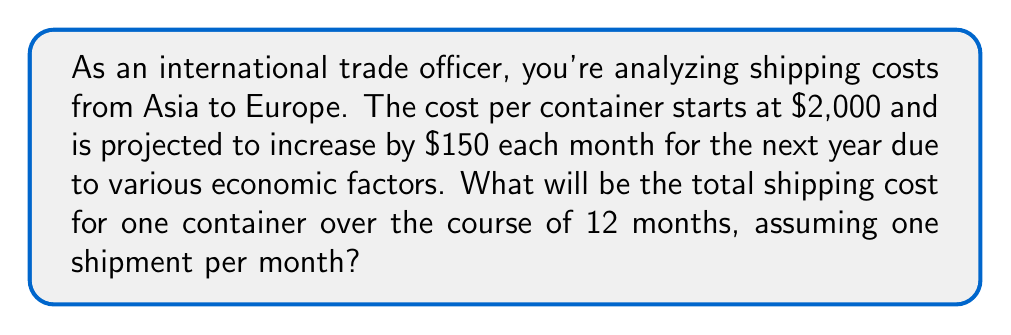Could you help me with this problem? Let's approach this step-by-step using arithmetic progression:

1) The initial term (a₁) is $2,000
2) The common difference (d) is $150
3) We need to find the sum of 12 terms

The arithmetic sequence is:
$2000, 2150, 2300, 2450, ...$

To find the sum, we can use the arithmetic series formula:

$$ S_n = \frac{n}{2}(a_1 + a_n) $$

Where:
$S_n$ is the sum of the series
$n$ is the number of terms (12)
$a_1$ is the first term ($2,000)
$a_n$ is the last term

To find $a_n$, we use the arithmetic sequence formula:
$$ a_n = a_1 + (n-1)d $$
$$ a_{12} = 2000 + (12-1)150 = 2000 + 1650 = 3650 $$

Now we can calculate the sum:

$$ S_{12} = \frac{12}{2}(2000 + 3650) = 6(5650) = 33,900 $$

Therefore, the total shipping cost over 12 months will be $33,900.
Answer: $33,900 